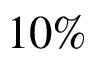Convert formula to latex. <formula><loc_0><loc_0><loc_500><loc_500>1 0 \%</formula> 